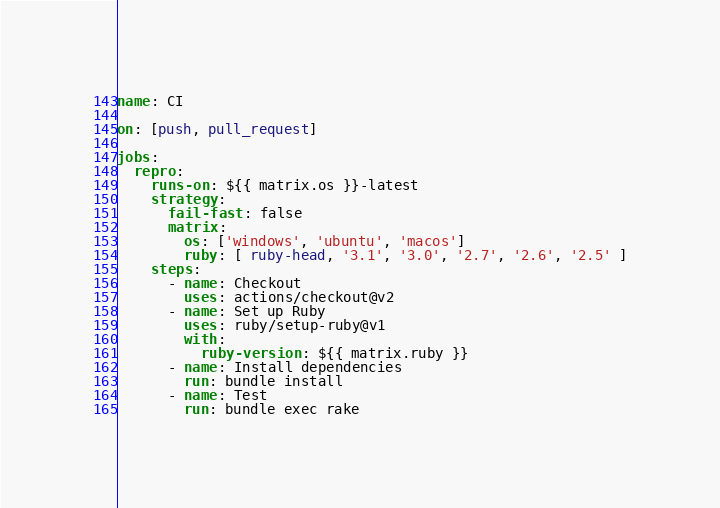<code> <loc_0><loc_0><loc_500><loc_500><_YAML_>name: CI

on: [push, pull_request]

jobs:
  repro:
    runs-on: ${{ matrix.os }}-latest
    strategy:
      fail-fast: false
      matrix:
        os: ['windows', 'ubuntu', 'macos']
        ruby: [ ruby-head, '3.1', '3.0', '2.7', '2.6', '2.5' ]
    steps:
      - name: Checkout
        uses: actions/checkout@v2
      - name: Set up Ruby
        uses: ruby/setup-ruby@v1
        with:
          ruby-version: ${{ matrix.ruby }}
      - name: Install dependencies
        run: bundle install
      - name: Test
        run: bundle exec rake
</code> 